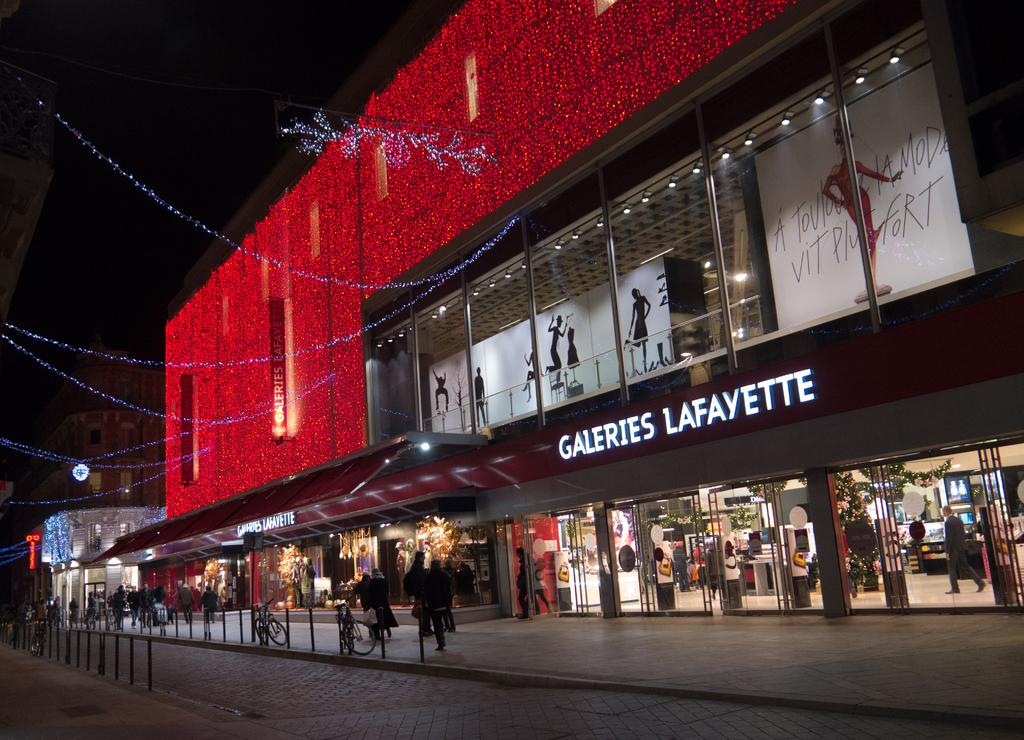What type of structures can be seen in the image? There are buildings in the image. What type of advertisements are present in the image? There are hoardings in the image. What type of illumination is visible in the image? There are lights in the image. What type of construction material is present in front of the building? Metal rods are present in front of the building. What type of transportation is visible in front of the building? Bicycles are visible in front of the building. What type of gathering is depicted in the image? There is a group of people in the image. What type of amusement can be seen in the image? There is no amusement present in the image; it features buildings, hoardings, lights, metal rods, bicycles, and a group of people. What shape is the store in the image? There is no store present in the image, so it is not possible to determine its shape. 